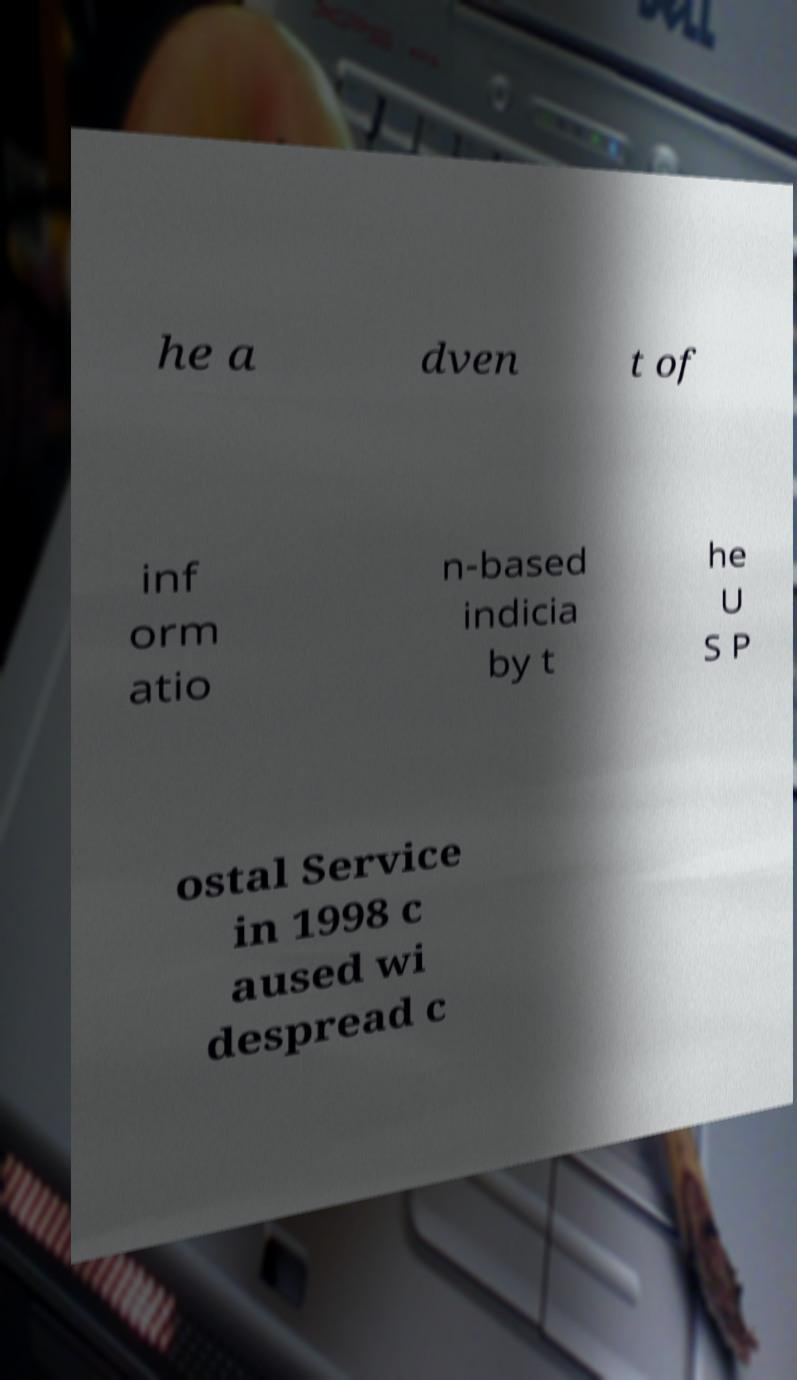Could you extract and type out the text from this image? he a dven t of inf orm atio n-based indicia by t he U S P ostal Service in 1998 c aused wi despread c 